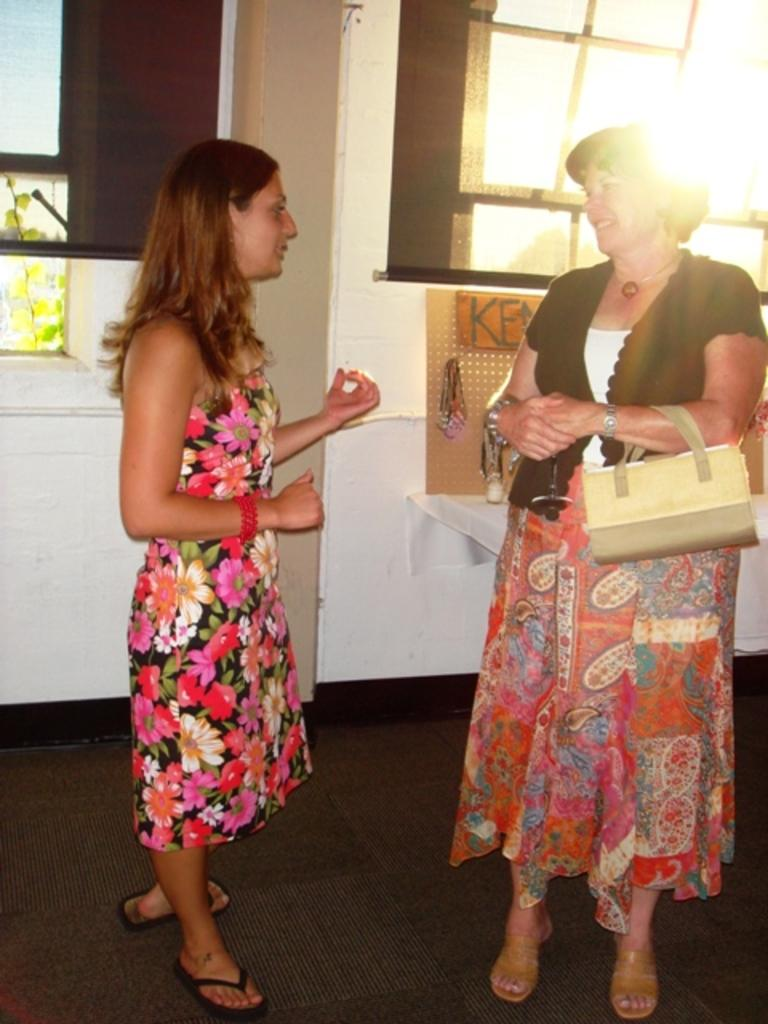How many women are present in the image? There are two women in the image. What is one of the women holding? One of the women is carrying a bag. What are the women doing in the image? The women are talking to each other. What can be seen in the background of the image? There is a window, a wall, and a name board in the background of the image. What is the reason for the picture being taken? The provided facts do not mention the reason for the picture being taken, so we cannot determine the reason from the image. 